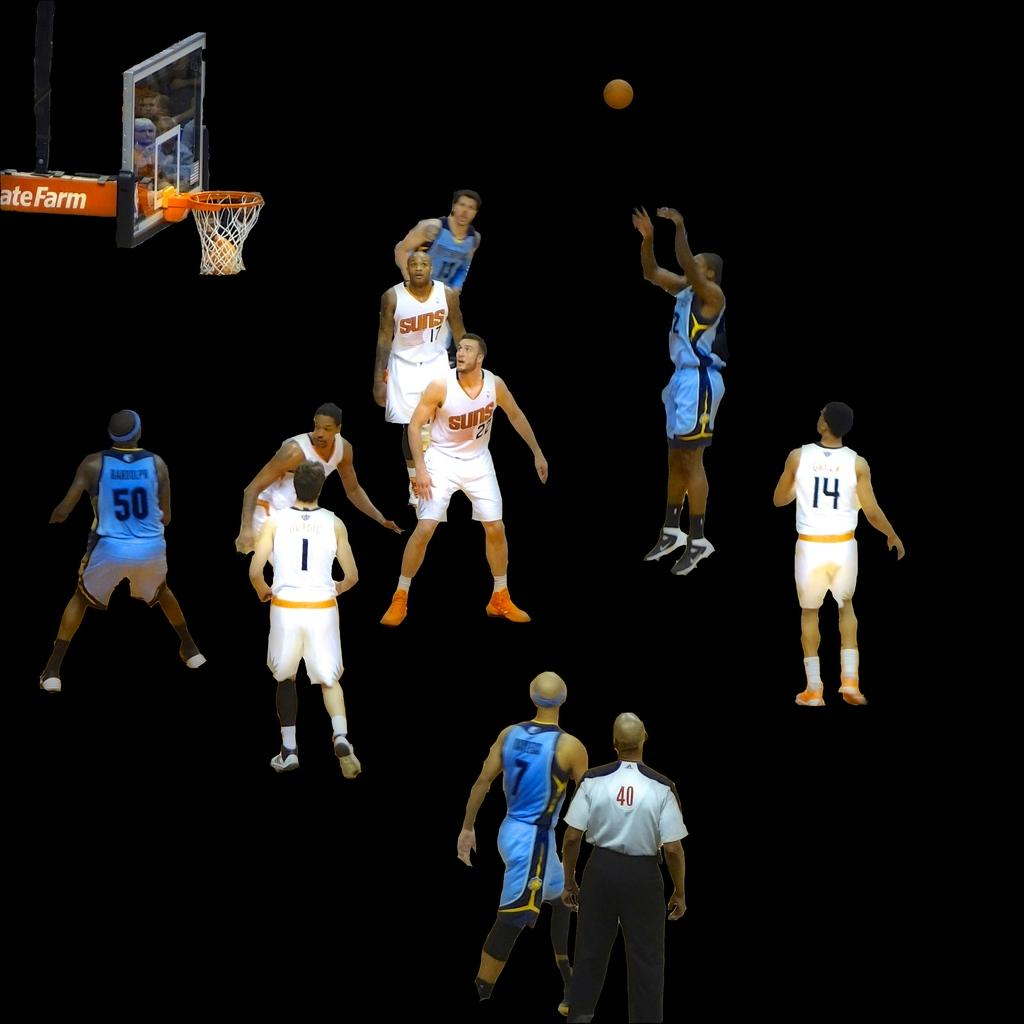<image>
Share a concise interpretation of the image provided. A basketball player in blue with the number 50 on his back 